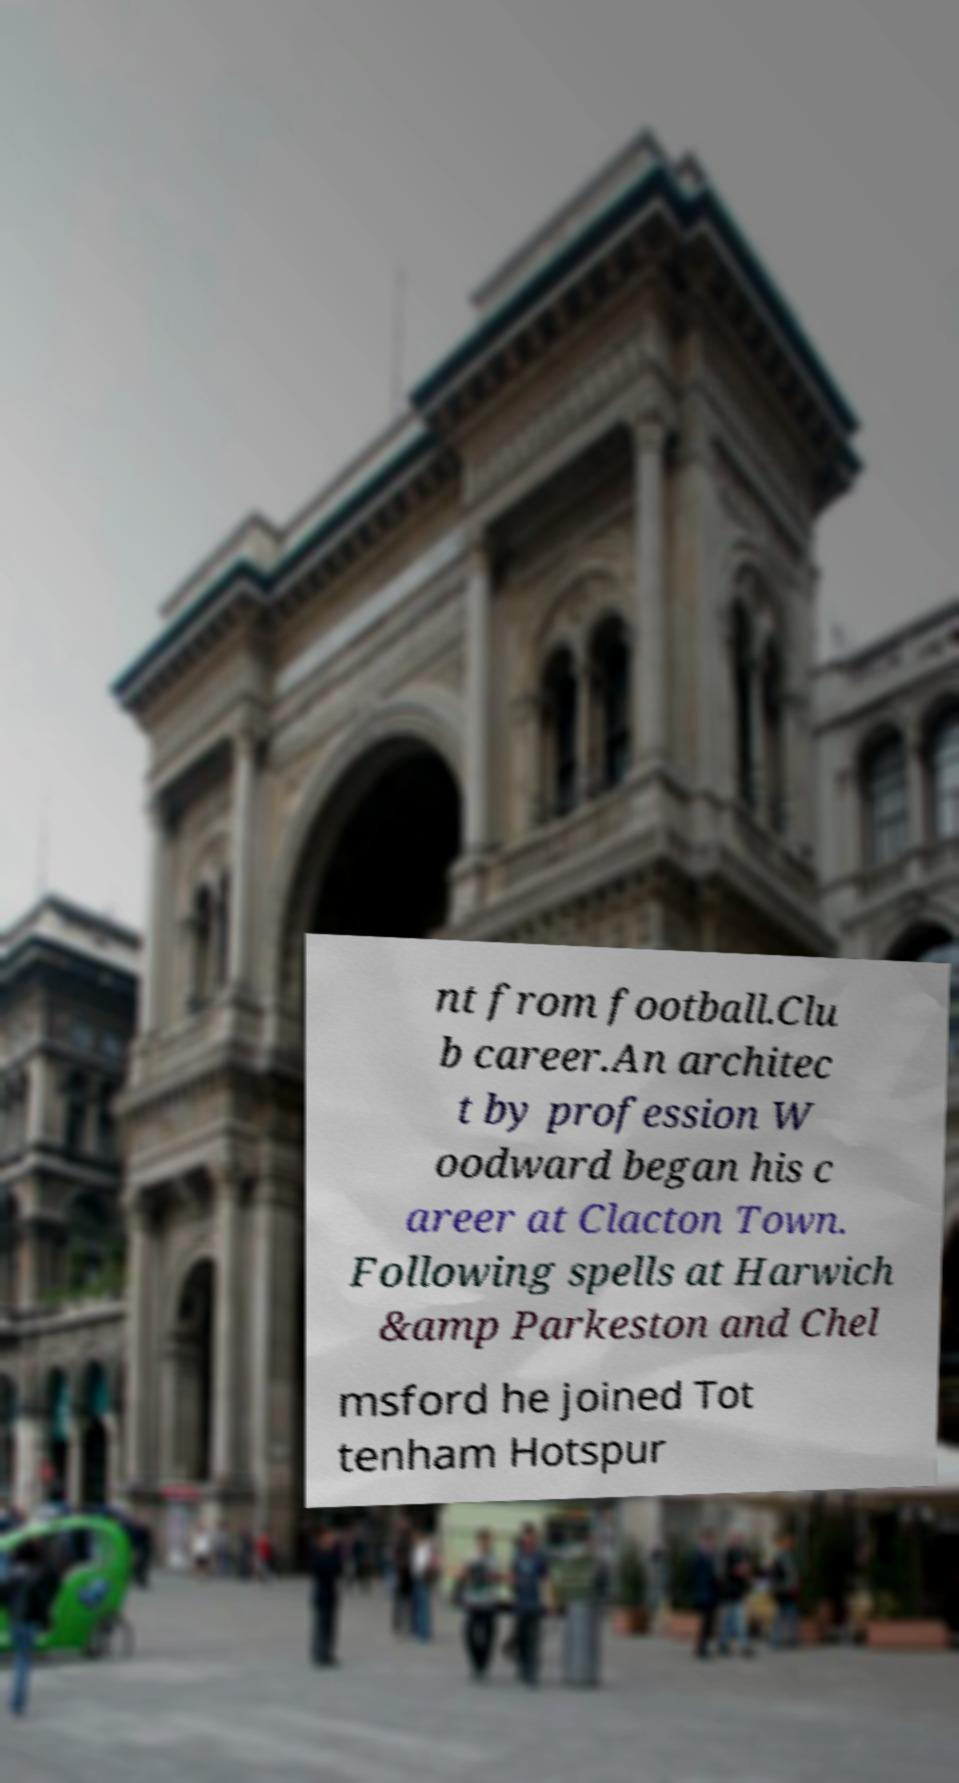Please read and relay the text visible in this image. What does it say? nt from football.Clu b career.An architec t by profession W oodward began his c areer at Clacton Town. Following spells at Harwich &amp Parkeston and Chel msford he joined Tot tenham Hotspur 